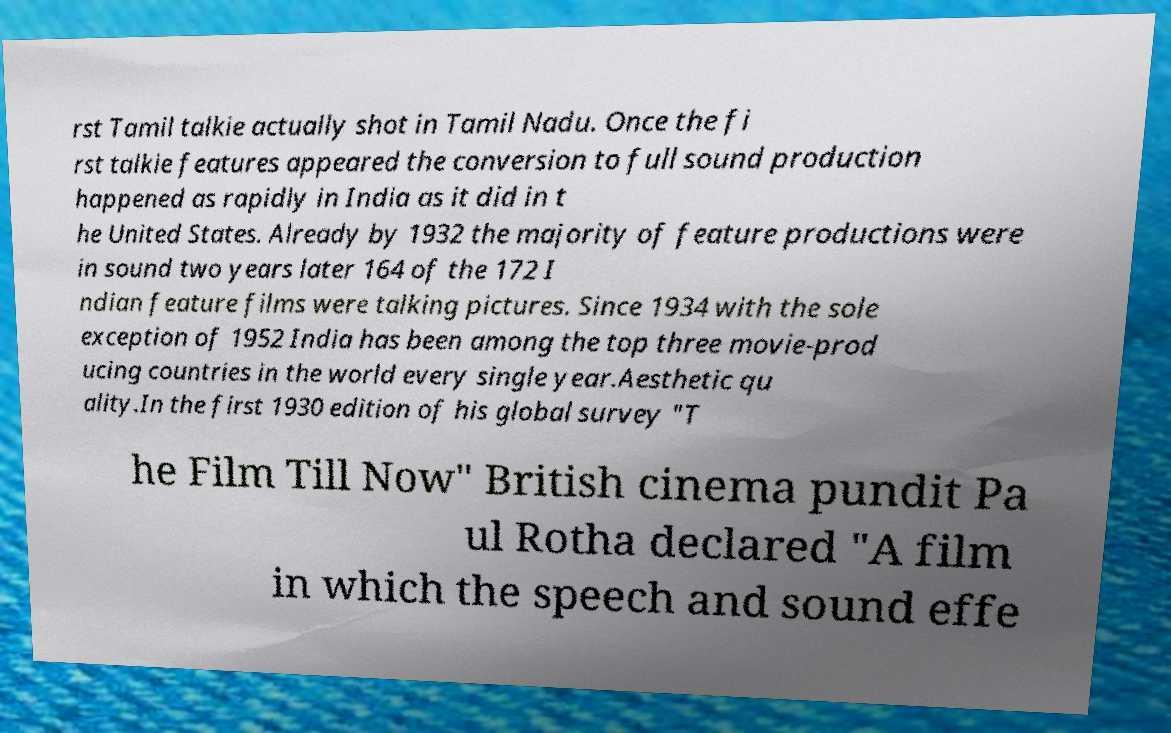For documentation purposes, I need the text within this image transcribed. Could you provide that? rst Tamil talkie actually shot in Tamil Nadu. Once the fi rst talkie features appeared the conversion to full sound production happened as rapidly in India as it did in t he United States. Already by 1932 the majority of feature productions were in sound two years later 164 of the 172 I ndian feature films were talking pictures. Since 1934 with the sole exception of 1952 India has been among the top three movie-prod ucing countries in the world every single year.Aesthetic qu ality.In the first 1930 edition of his global survey "T he Film Till Now" British cinema pundit Pa ul Rotha declared "A film in which the speech and sound effe 